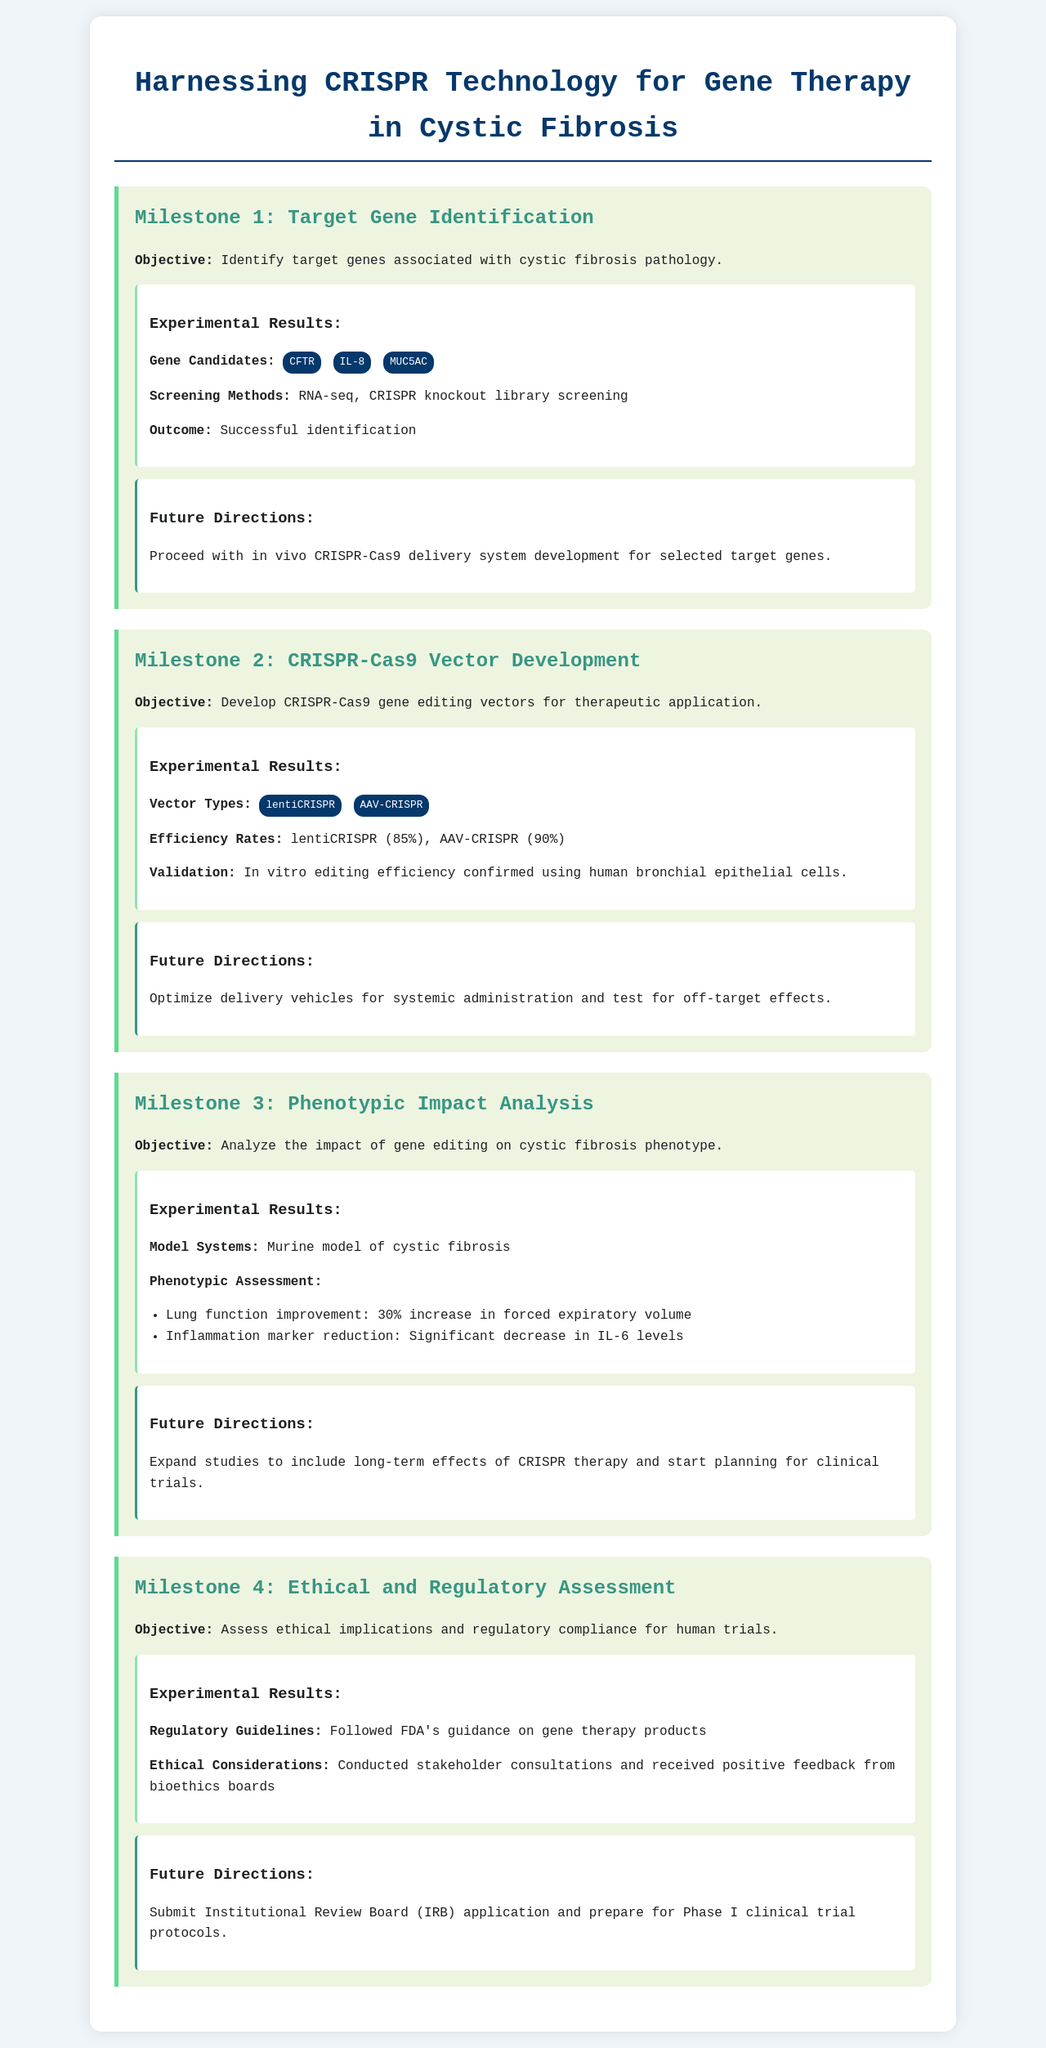What are the target genes identified for cystic fibrosis? The target genes associated with cystic fibrosis pathology are listed in the document as gene candidates.
Answer: CFTR, IL-8, MUC5AC What percentage is the editing efficiency of AAV-CRISPR? The document states the efficiency rates of the developed vectors, including AAV-CRISPR.
Answer: 90% What is the lung function improvement percentage observed in the murine model? The phenotypic assessment section of the document details the lung function improvement resulting from gene editing.
Answer: 30% Which regulatory guidelines were followed for the project? The experimental results section mentions the regulatory guidelines adhered to in the project.
Answer: FDA's guidance on gene therapy products What future direction follows the analysis of phenotypic impact? The directions for future studies are detailed after the phenotypic impact analysis.
Answer: Expand studies to include long-term effects of CRISPR therapy and start planning for clinical trials What type of gene editing vector achieved an 85% efficiency rate? The results section provides efficiency rates for different vector types developed during the project.
Answer: lentiCRISPR What type of model system was used in the phenotypic impact analysis? The document specifies the model used to assess the impact of gene editing on cystic fibrosis phenotype.
Answer: Murine model What stakeholder feedback was received regarding ethical considerations? The results section describes the outcome of the consultations conducted regarding ethical implications.
Answer: Positive feedback from bioethics boards What is the next step in the development of CRISPR-Cas9 delivery systems? The future directions listed after Milestone 1 indicate the next steps for development.
Answer: Proceed with in vivo CRISPR-Cas9 delivery system development for selected target genes 